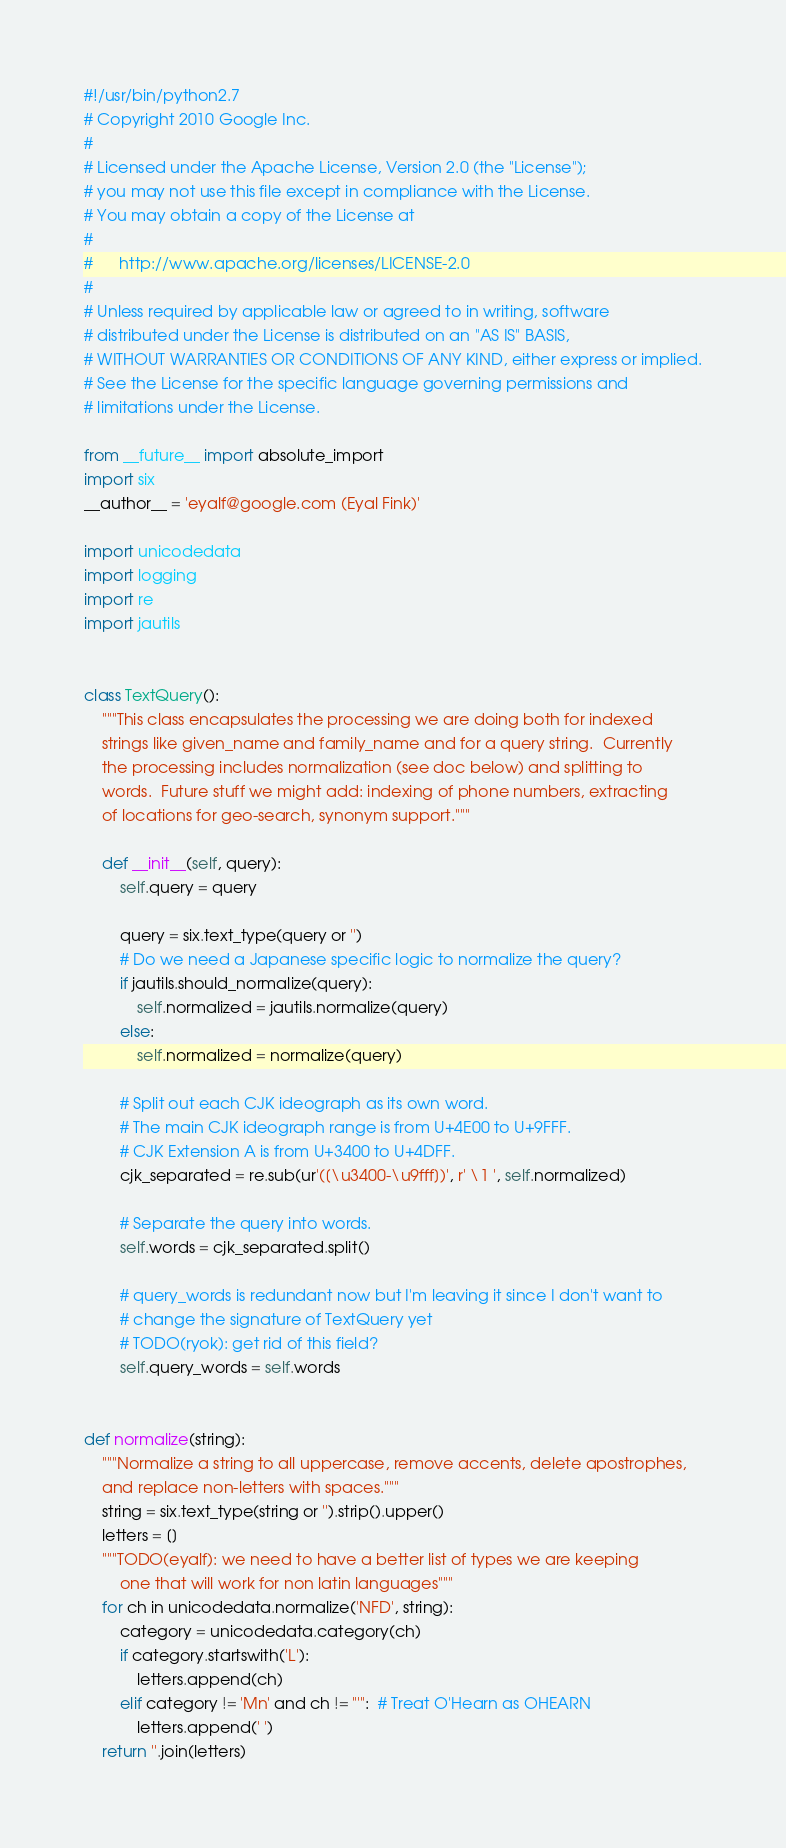Convert code to text. <code><loc_0><loc_0><loc_500><loc_500><_Python_>#!/usr/bin/python2.7
# Copyright 2010 Google Inc.
#
# Licensed under the Apache License, Version 2.0 (the "License");
# you may not use this file except in compliance with the License.
# You may obtain a copy of the License at
#
#      http://www.apache.org/licenses/LICENSE-2.0
#
# Unless required by applicable law or agreed to in writing, software
# distributed under the License is distributed on an "AS IS" BASIS,
# WITHOUT WARRANTIES OR CONDITIONS OF ANY KIND, either express or implied.
# See the License for the specific language governing permissions and
# limitations under the License.

from __future__ import absolute_import
import six
__author__ = 'eyalf@google.com (Eyal Fink)'

import unicodedata
import logging
import re
import jautils


class TextQuery():
    """This class encapsulates the processing we are doing both for indexed
    strings like given_name and family_name and for a query string.  Currently
    the processing includes normalization (see doc below) and splitting to
    words.  Future stuff we might add: indexing of phone numbers, extracting
    of locations for geo-search, synonym support."""

    def __init__(self, query):
        self.query = query

        query = six.text_type(query or '')
        # Do we need a Japanese specific logic to normalize the query?
        if jautils.should_normalize(query):
            self.normalized = jautils.normalize(query)
        else:
            self.normalized = normalize(query)

        # Split out each CJK ideograph as its own word.
        # The main CJK ideograph range is from U+4E00 to U+9FFF.
        # CJK Extension A is from U+3400 to U+4DFF.
        cjk_separated = re.sub(ur'([\u3400-\u9fff])', r' \1 ', self.normalized)

        # Separate the query into words.
        self.words = cjk_separated.split()

        # query_words is redundant now but I'm leaving it since I don't want to
        # change the signature of TextQuery yet
        # TODO(ryok): get rid of this field?
        self.query_words = self.words


def normalize(string):
    """Normalize a string to all uppercase, remove accents, delete apostrophes,
    and replace non-letters with spaces."""
    string = six.text_type(string or '').strip().upper()
    letters = []
    """TODO(eyalf): we need to have a better list of types we are keeping
        one that will work for non latin languages"""
    for ch in unicodedata.normalize('NFD', string):
        category = unicodedata.category(ch)
        if category.startswith('L'):
            letters.append(ch)
        elif category != 'Mn' and ch != "'":  # Treat O'Hearn as OHEARN
            letters.append(' ')
    return ''.join(letters)
</code> 